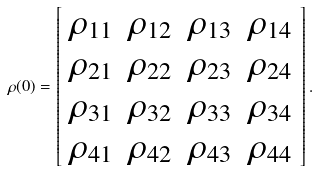Convert formula to latex. <formula><loc_0><loc_0><loc_500><loc_500>\rho ( 0 ) = \left [ \begin{array} { c c c c } \rho _ { 1 1 } & \rho _ { 1 2 } & \rho _ { 1 3 } & \rho _ { 1 4 } \\ \rho _ { 2 1 } & \rho _ { 2 2 } & \rho _ { 2 3 } & \rho _ { 2 4 } \\ \rho _ { 3 1 } & \rho _ { 3 2 } & \rho _ { 3 3 } & \rho _ { 3 4 } \\ \rho _ { 4 1 } & \rho _ { 4 2 } & \rho _ { 4 3 } & \rho _ { 4 4 } \end{array} \right ] .</formula> 